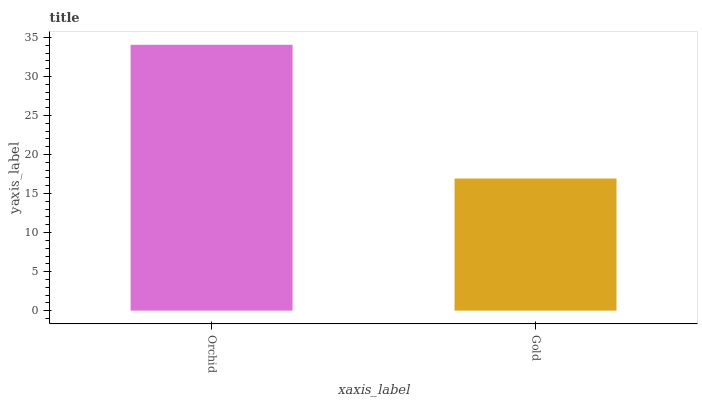Is Gold the minimum?
Answer yes or no. Yes. Is Orchid the maximum?
Answer yes or no. Yes. Is Gold the maximum?
Answer yes or no. No. Is Orchid greater than Gold?
Answer yes or no. Yes. Is Gold less than Orchid?
Answer yes or no. Yes. Is Gold greater than Orchid?
Answer yes or no. No. Is Orchid less than Gold?
Answer yes or no. No. Is Orchid the high median?
Answer yes or no. Yes. Is Gold the low median?
Answer yes or no. Yes. Is Gold the high median?
Answer yes or no. No. Is Orchid the low median?
Answer yes or no. No. 